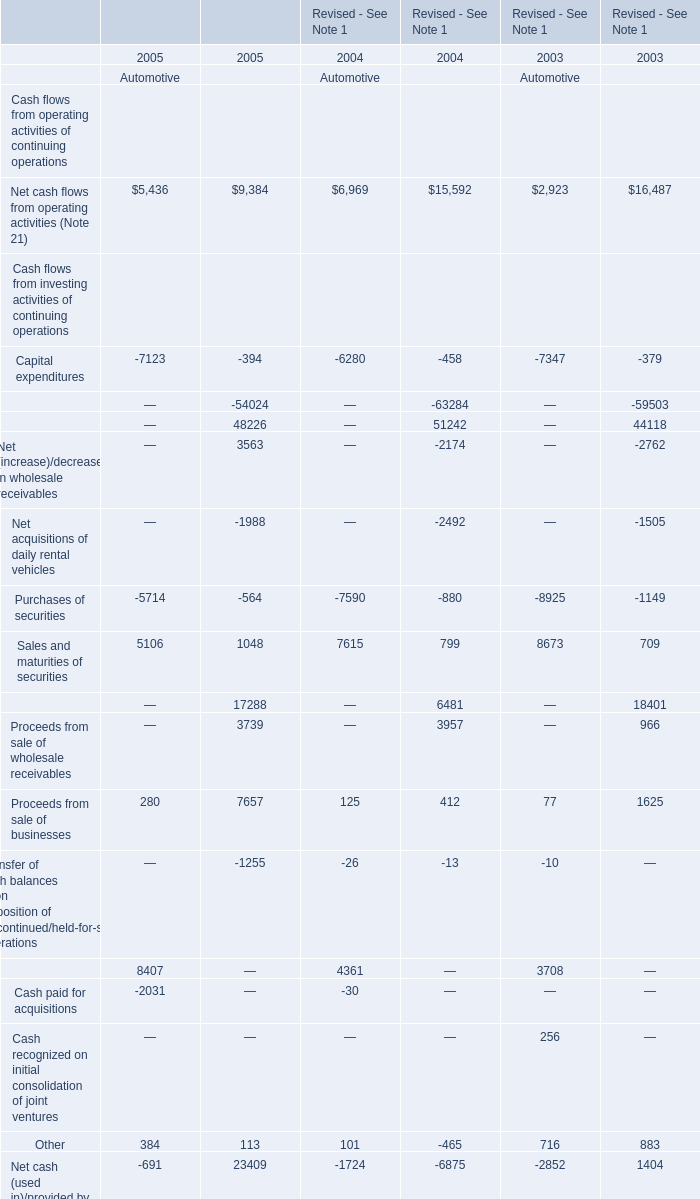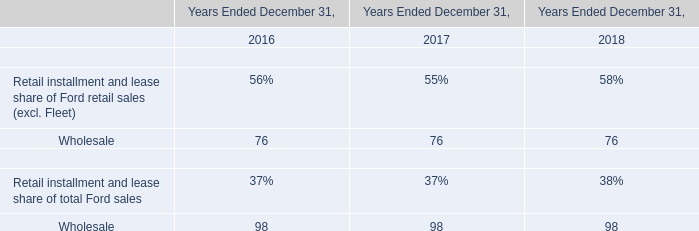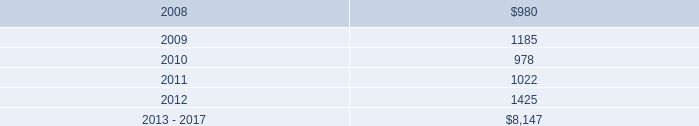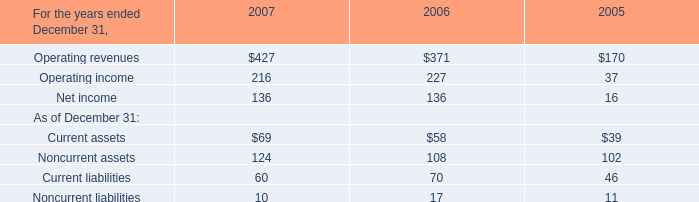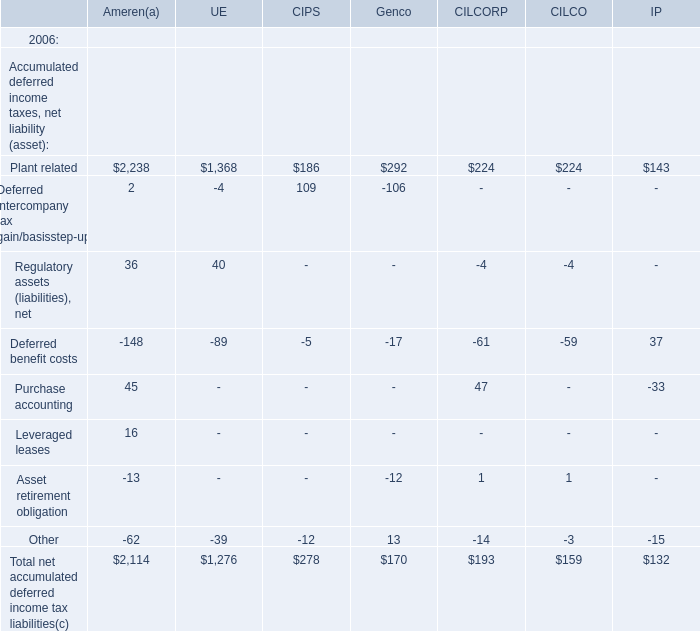What is the growing rate of Other in the year with the most Net cash flows from operating activities (Note 21)? 
Computations: (((384 + 113) - (101 - 465)) / (101 - 465))
Answer: -2.36538. 